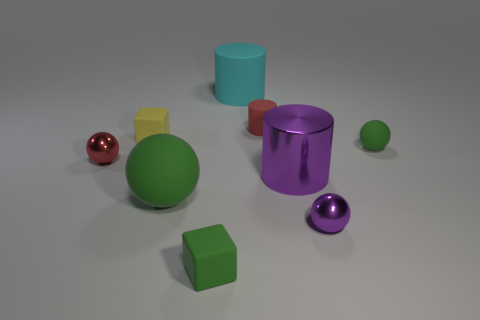Which objects in the image could potentially roll? The objects in the image that have the potential to roll are the spheres due to their circular shape. This includes the green sphere, the red sphere, and the purple sphere. Their smooth, round surfaces would allow them to move across flat surfaces if a force were applied. 